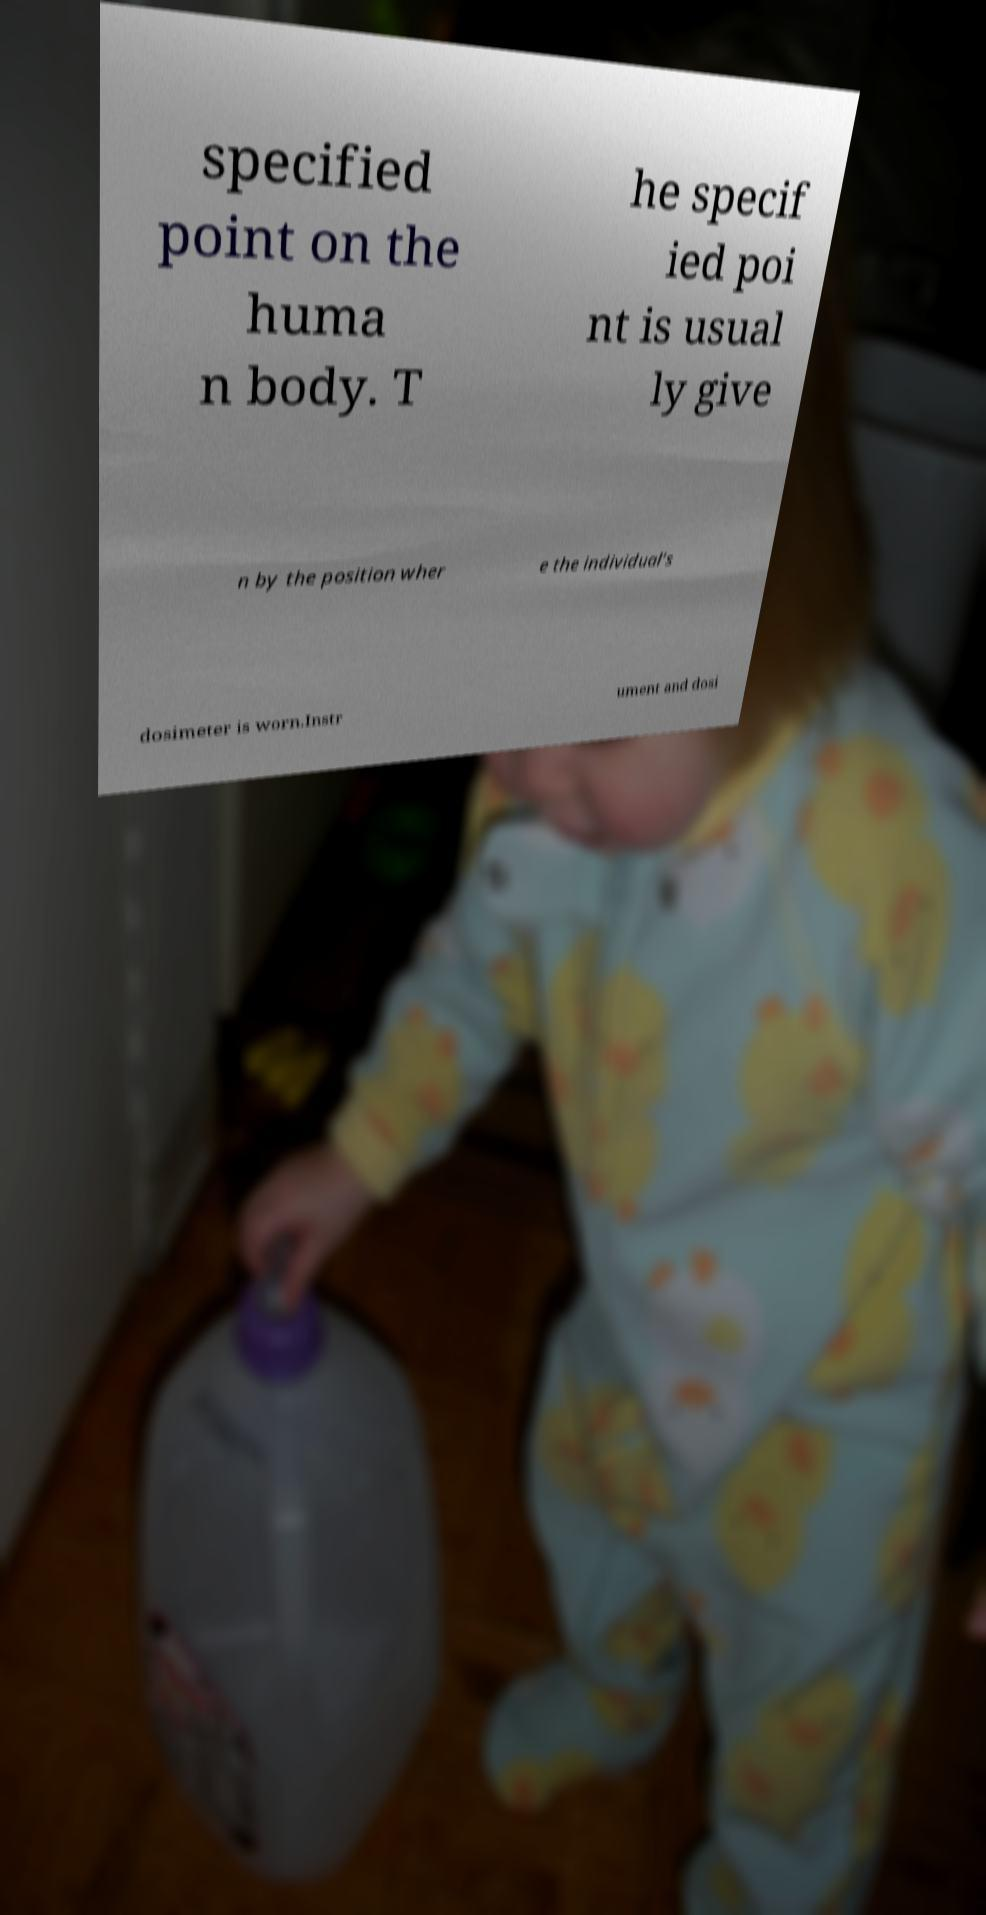I need the written content from this picture converted into text. Can you do that? specified point on the huma n body. T he specif ied poi nt is usual ly give n by the position wher e the individual’s dosimeter is worn.Instr ument and dosi 